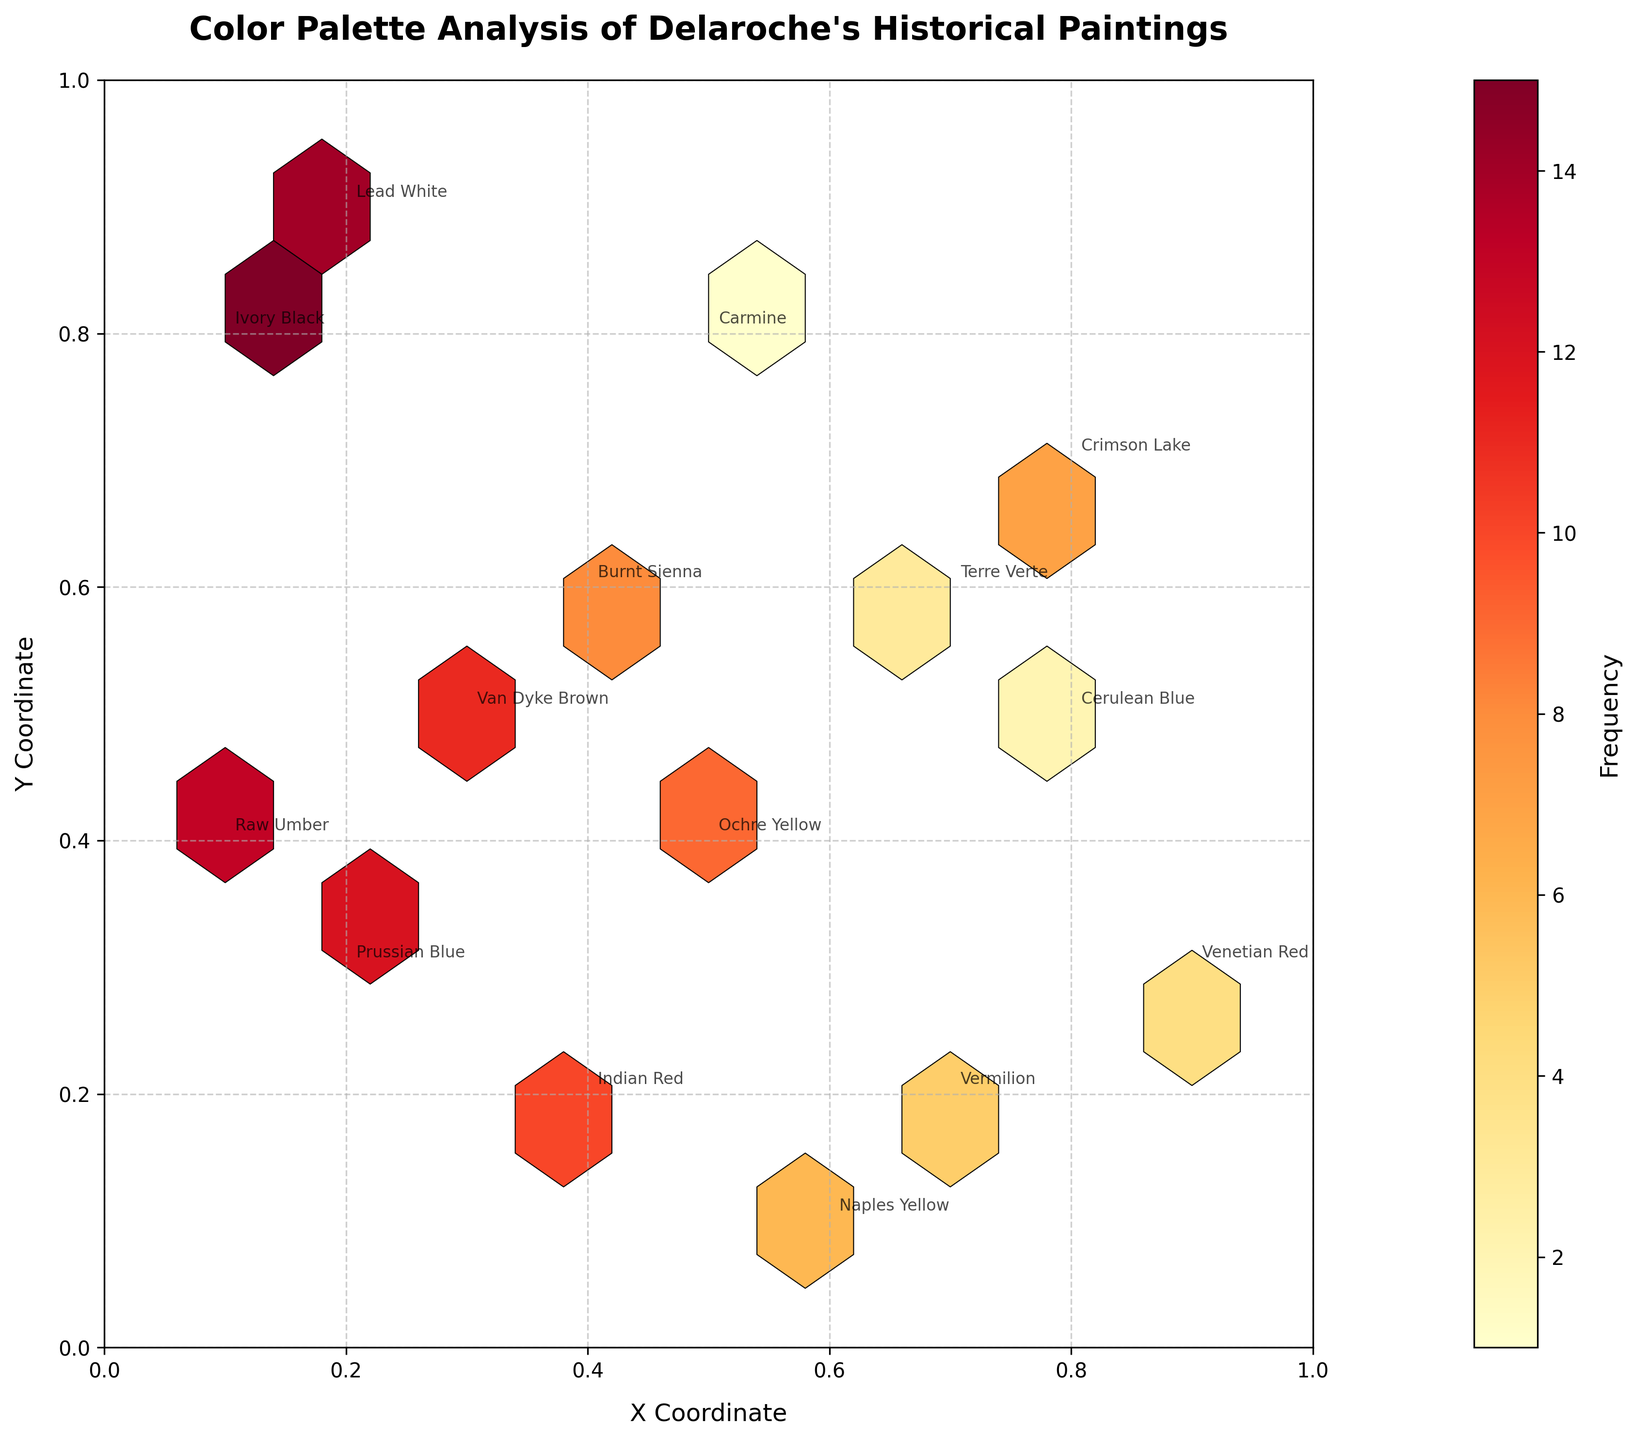what is the title of the plot? The title of the plot is displayed prominently at the top of the figure. It provides an overview of what the plot represents.
Answer: "Color Palette Analysis of Delaroche's Historical Paintings" how many data points are represented in the plot? Each data point corresponds to a specific color in Delaroche's paintings and is marked by an annotation. By counting these annotations, one can determine the number of data points.
Answer: 14 which color has the highest frequency? By looking at the color bar and identifying the hexagon with the highest frequency value, you can see which color is annotated near it. Observing the hexagon with the maximum frequency reveals that the color is Ivory Black.
Answer: Ivory Black what is the frequency of Carmine? Locate the annotation "Carmine" in the plot and refer to the color bar to see the corresponding frequency value. It's efficient to check the frequency and find the value near the annotation.
Answer: 1 what coordinates is the color Burnt Sienna located? Locate the annotation "Burnt Sienna" on the figure and note its corresponding x and y coordinates. The annotation is situated near the coordinates (0.4, 0.6).
Answer: (0.4, 0.6) how many colors have a frequency greater than 10? Count the number of annotations that have a frequency value greater than 10 by referring to the color bar. The colors with frequencies above 10 include Prussian Blue, Ivory Black, Lead White, and Raw Umber.
Answer: 4 what color is closest to the coordinates (0.7, 0.6)? Identify the annotation closest to the coordinates (0.7, 0.6) on the plot. By observing the plot, the closest color to this coordinate is Terre Verte.
Answer: Terre Verte which colors are situated in the x range of 0.1 to 0.3? Locate annotations between x coordinates of 0.1 and 0.3 by scanning the plot horizontally within this range. The annotations in this range include Prussian Blue, Ivory Black, Lead White, and Raw Umber.
Answer: Prussian Blue, Ivory Black, Lead White, Raw Umber what is the average frequency of colors in the y range of 0.5 to 0.8? Identify the colors within the y range of 0.5 to 0.8: Burnt Sienna, Van Dyke Brown, Carmine, and Lead White. Sum their frequencies (8 + 11 + 1 + 14 = 34) and divide by the number of colors (4) to find the average.
Answer: 8.5 which color has the lowest frequency? Identify the annotation near the minimum frequency value by referencing the color bar and its corresponding hexagon. The color with the lowest frequency is Carmine.
Answer: Carmine 